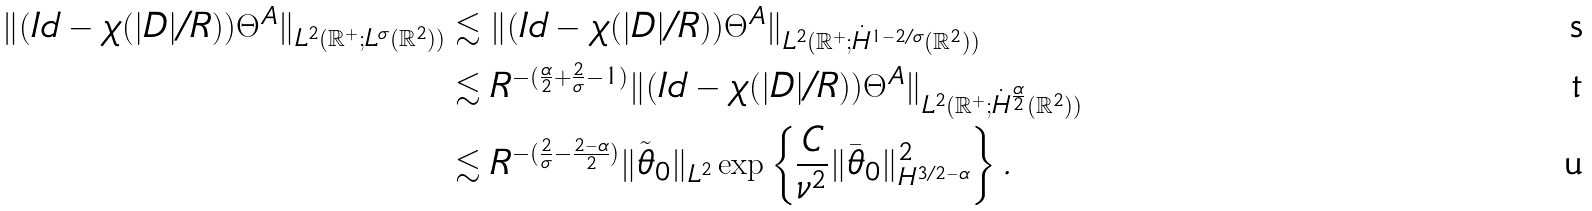Convert formula to latex. <formula><loc_0><loc_0><loc_500><loc_500>\| ( I d - \chi ( | D | / R ) ) \Theta ^ { A } \| _ { L ^ { 2 } ( \mathbb { R } ^ { + } ; L ^ { \sigma } ( \mathbb { R } ^ { 2 } ) ) } & \lesssim \| ( I d - \chi ( | D | / R ) ) \Theta ^ { A } \| _ { L ^ { 2 } ( \mathbb { R } ^ { + } ; \dot { H } ^ { 1 - 2 / \sigma } ( \mathbb { R } ^ { 2 } ) ) } \\ & \lesssim R ^ { - ( \frac { \alpha } { 2 } + \frac { 2 } { \sigma } - 1 ) } \| ( I d - \chi ( | D | / R ) ) \Theta ^ { A } \| _ { L ^ { 2 } ( \mathbb { R } ^ { + } ; \dot { H } ^ { \frac { \alpha } { 2 } } ( \mathbb { R } ^ { 2 } ) ) } \\ & \lesssim R ^ { - ( \frac { 2 } { \sigma } - \frac { 2 - \alpha } { 2 } ) } \| \tilde { \theta } _ { 0 } \| _ { L ^ { 2 } } \exp \left \{ \frac { C } { \nu ^ { 2 } } \| \bar { \theta } _ { 0 } \| _ { H ^ { 3 / 2 - \alpha } } ^ { 2 } \right \} .</formula> 